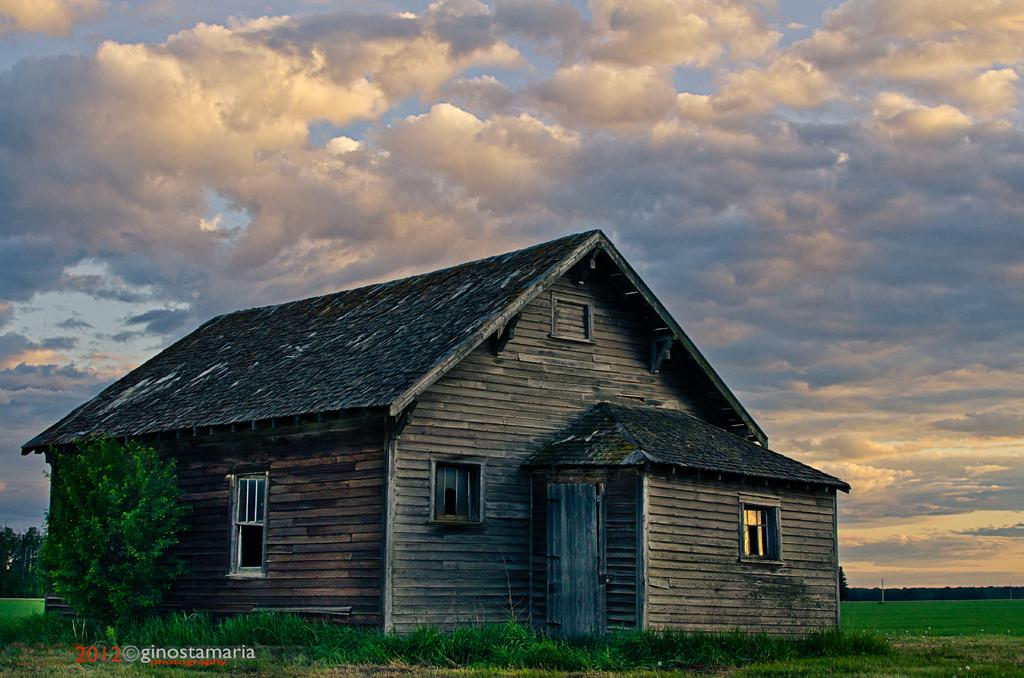What is the main structure in the center of the image? There is a shed in the center of the image. What type of vegetation is on the left side of the image? There is a tree on the left side of the image. What can be seen in the background of the image? The sky is visible in the background of the image. What type of ground is present at the bottom of the image? There is grass at the bottom of the image. How many flies can be seen on the floor in the image? There is no floor present in the image, and therefore no flies can be seen. 